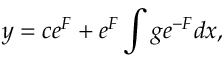<formula> <loc_0><loc_0><loc_500><loc_500>y = c e ^ { F } + e ^ { F } \int g e ^ { - F } d x ,</formula> 